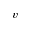Convert formula to latex. <formula><loc_0><loc_0><loc_500><loc_500>v</formula> 